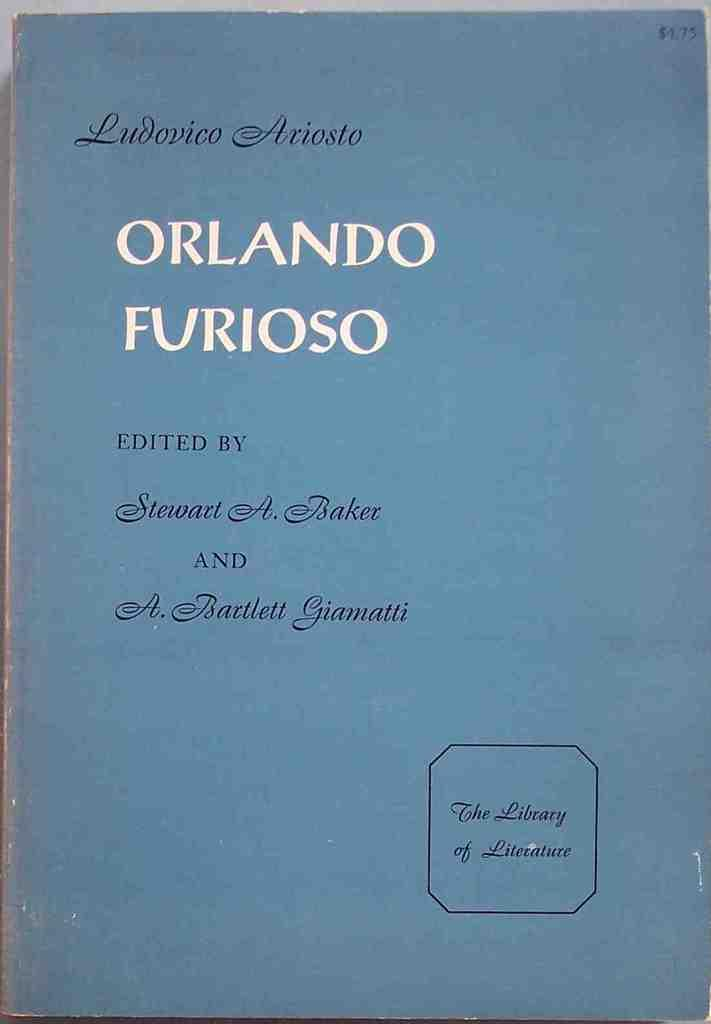<image>
Write a terse but informative summary of the picture. A book cover with the title Orlando Furioso printed on the front. 